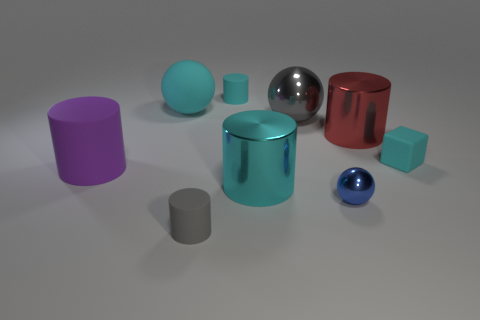Is the small block the same color as the rubber sphere?
Provide a short and direct response. Yes. There is a cyan cube that is in front of the cyan rubber sphere; is it the same size as the tiny blue object?
Ensure brevity in your answer.  Yes. How many large cyan cylinders are right of the big ball right of the small gray rubber cylinder?
Your answer should be very brief. 0. Are there any blue shiny objects behind the small cyan thing that is on the right side of the cylinder that is behind the big red metal cylinder?
Give a very brief answer. No. There is a small blue thing that is the same shape as the large gray object; what is its material?
Offer a terse response. Metal. Are the tiny sphere and the tiny cyan object that is on the left side of the big gray object made of the same material?
Ensure brevity in your answer.  No. The cyan rubber thing on the left side of the tiny cylinder that is behind the purple matte object is what shape?
Ensure brevity in your answer.  Sphere. How many tiny objects are either red cylinders or red blocks?
Ensure brevity in your answer.  0. What number of other big red shiny objects are the same shape as the red thing?
Your answer should be compact. 0. There is a large cyan metal object; is its shape the same as the large rubber object in front of the cyan rubber cube?
Ensure brevity in your answer.  Yes. 